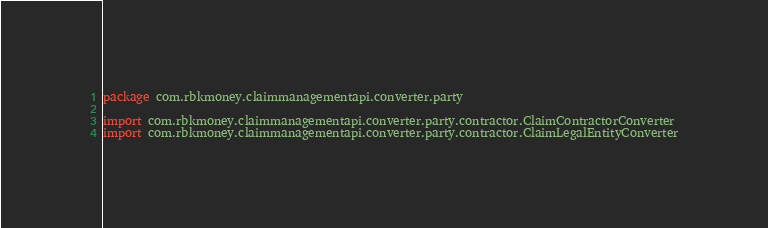Convert code to text. <code><loc_0><loc_0><loc_500><loc_500><_Kotlin_>package com.rbkmoney.claimmanagementapi.converter.party

import com.rbkmoney.claimmanagementapi.converter.party.contractor.ClaimContractorConverter
import com.rbkmoney.claimmanagementapi.converter.party.contractor.ClaimLegalEntityConverter</code> 